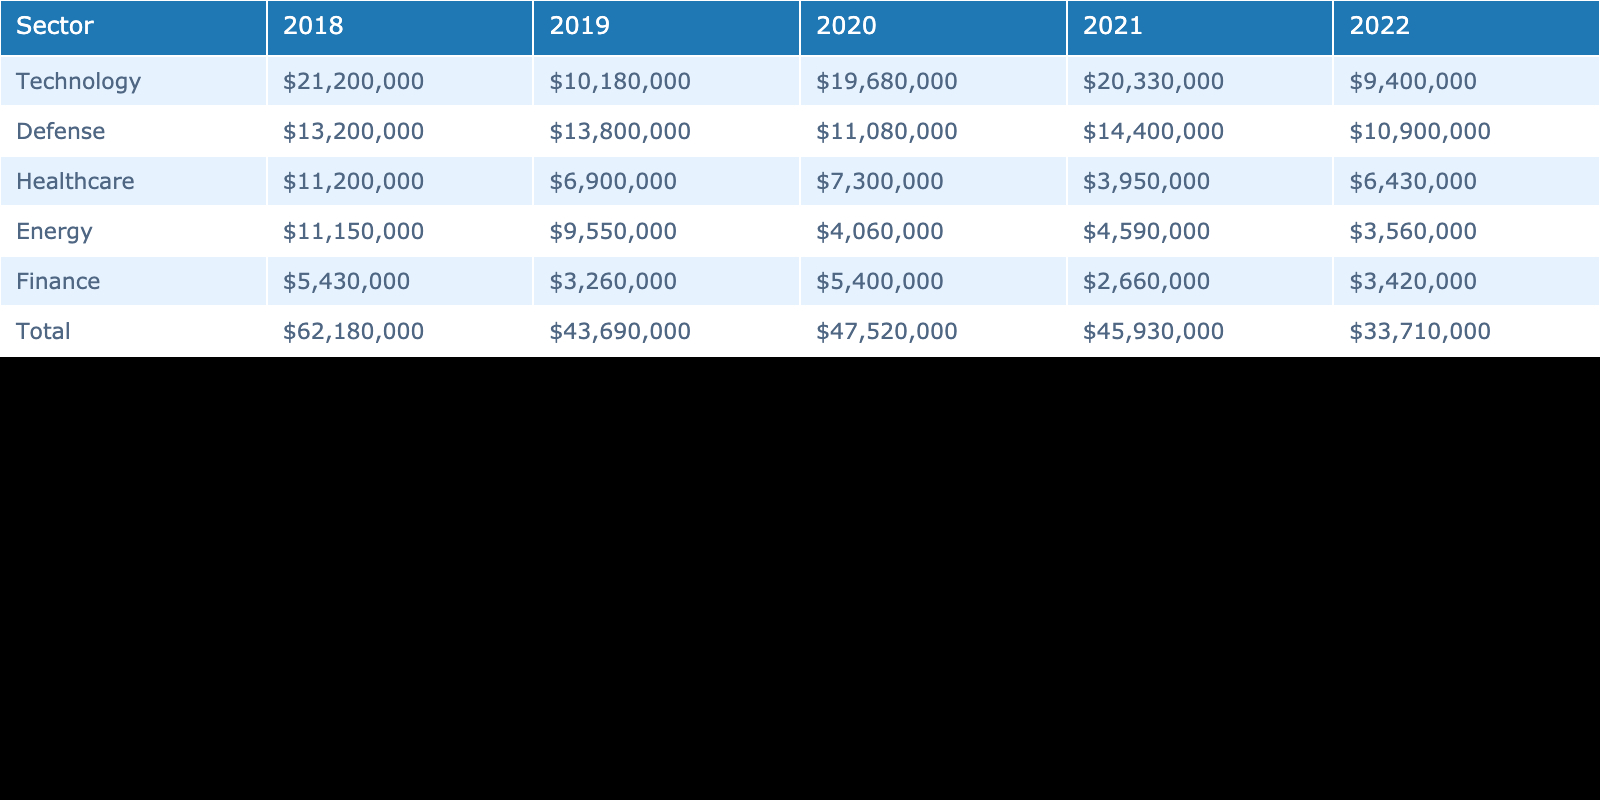What sector had the highest total lobbying expenditure over the past 5 years? By looking at the total row at the bottom of the table, we can identify the sector with the highest value. In this case, the sector with the highest total lobbying expenditure is Technology, with a total of $113,200,000.
Answer: Technology Which sector spent $6,430,000 in lobbying in 2022? Referring to the 2022 column for each sector, we find that Healthcare is listed with an expenditure of $6,430,000.
Answer: Healthcare What was the total lobbying expenditure for Healthcare across all years? To find this, we need to sum the expenditures for the Healthcare sector across each year listed in the table. The values are $11,200,000 (2018) + $6,900,000 (2019) + $7,300,000 (2020) + $3,950,000 (2021) + $6,430,000 (2022) = $35,780,000.
Answer: $35,780,000 Did the Defense sector have an increase in lobbying expenditure from 2019 to 2021? By examining the values in the Defense row for both years, in 2019 it was $13,800,000 and in 2021 it increased to $14,400,000. Since $14,400,000 is greater than $13,800,000, this indicates an increase.
Answer: Yes What was the average lobbying expenditure for the Energy sector over the last 5 years? First, we find the expenditures listed for the Energy sector: $11,150,000 (2018), $9,550,000 (2019), $4,060,000 (2020), $4,590,000 (2021), and $3,560,000 (2022). Summing these gives us $32,910,000, and averaging over 5 years yields $32,910,000 / 5 = $6,582,000.
Answer: $6,582,000 What was the total lobbying expenditure for the Finance sector across the years 2018 to 2022? To find this, we need to add the expenditures from each year for the Finance sector: $5,430,000 (2018) + $3,260,000 (2019) + $5,400,000 (2020) + $2,660,000 (2021) + $3,420,000 (2022) = $20,170,000.
Answer: $20,170,000 Is it true that in 2020, the expenditure for Technology was higher than that for Defense? Checking the table, the expenditure for Technology in 2020 was $19,680,000 and for Defense, it was $11,080,000. Since $19,680,000 is greater than $11,080,000, the statement is true.
Answer: Yes Which company had the highest expenditure in the Technology sector in 2021? Looking at the Technology row for 2021 in the table shows that Amazon had an expenditure of $20,330,000, which is the highest for that year.
Answer: Amazon 